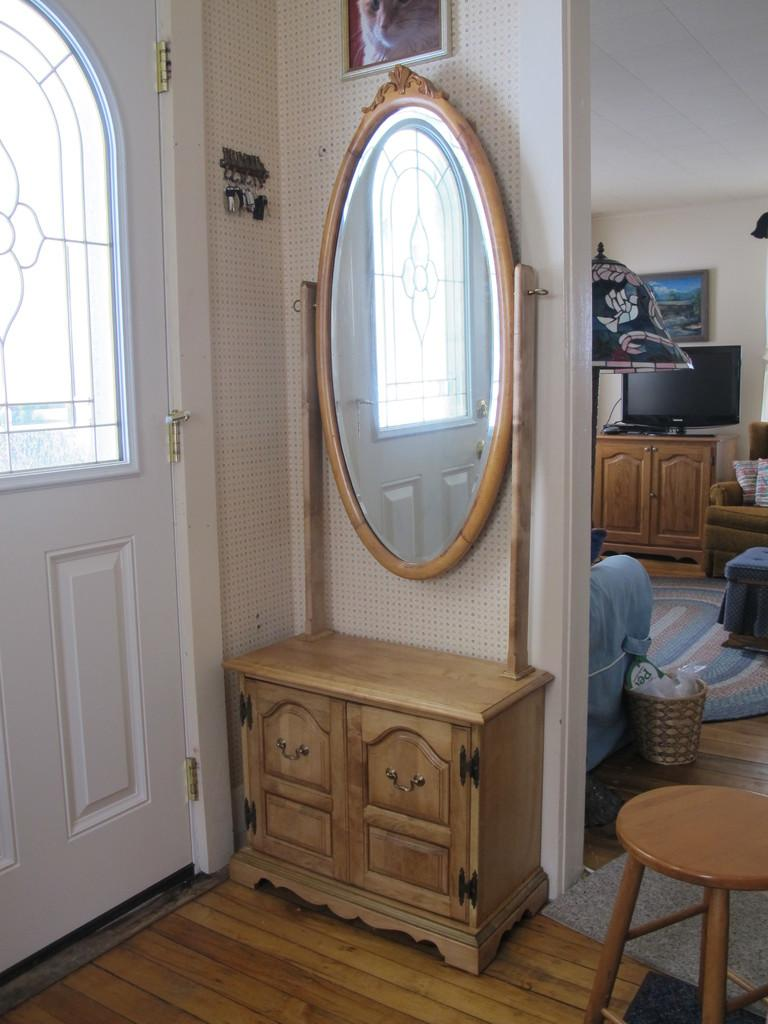What type of reflective surface is present in the image? There is a mirror in the image. What type of storage compartment is visible in the image? There is a drawer in the image. What is located on the left side of the image? There is a door on the left side of the image. What type of electronic device is present in the image? There is a television in the image. What type of decorative item is present in the image? There is a photo frame in the image. What type of object is used for unlocking in the image? There are keys placed in the image. What type of sugar is visible in the image? There is no sugar present in the image. How does the thumb interact with the mirror in the image? There is no thumb present in the image, and therefore no interaction with the mirror can be observed. 